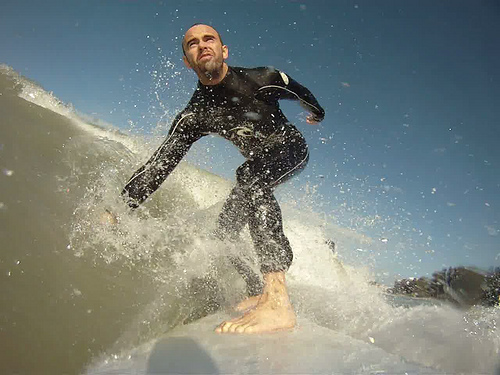What might the surfer do after this successful maneuver? After completing this successful maneuver, the surfer would likely continue to ride the wave to its full potential before gliding back out to catch the next one. He might take a brief moment to relish the accomplishment, feeling the rush of adrenaline and satisfaction from a well-executed ride. Once back to the calmer waters, he would reposition himself, scanning the horizon for the next promising wave. How does the environment impact the surfer's experience? The environment significantly impacts the surfer's experience. The clear skies and bright sunlight create an uplifting and energizing atmosphere, while the ocean conditions—wave size, swell direction, and water temperature—directly affect the quality of the surf. The sound of crashing waves and the salty scent of the sea further immerse the surfer, heightening sensory engagement and connection to nature. Together, these environmental elements contribute to a holistic and emotionally enriching surfing experience. If the surfer could speak directly to the wave, what might he say? "Thank you for this moment of pure freedom and exhilaration. You challenge me, push my limits, and offer joy in ways nothing else can. To ride you is to feel truly alive, to connect with the heartbeat of the ocean. Until the next wave, I am grateful for every ride you give me." 